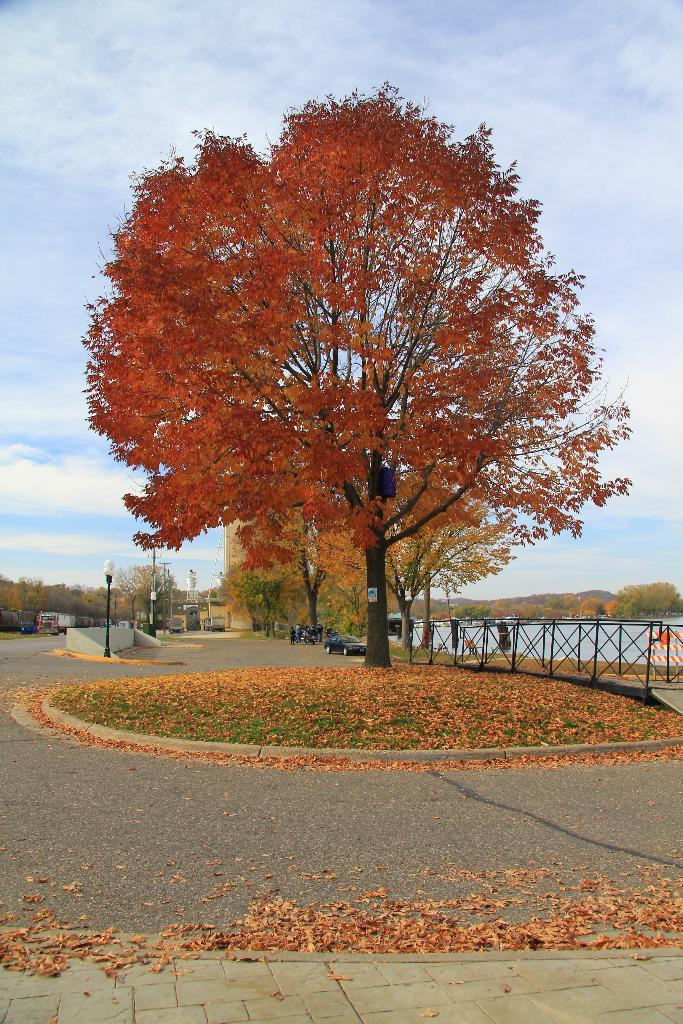What type of natural element can be seen in the image? There is a tree in the image. What type of man-made structure is visible in the image? There is a path in the image. What are the vehicles parked on in the image? The vehicles are parked on the road behind the tree. What type of barrier is present in the image? There is a fence in the image. What type of lighting fixture is present in the image? There is a pole with a light in the image. What type of liquid is visible in the image? There is water visible in the image. What type of geographical feature can be seen in the background of the image? There are hills in the background of the image. What part of the natural environment is visible in the image? The sky is visible in the image. What type of sponge is being used to clean the queen's teeth in the image? There is no queen or sponge present in the image, and therefore no such activity can be observed. 